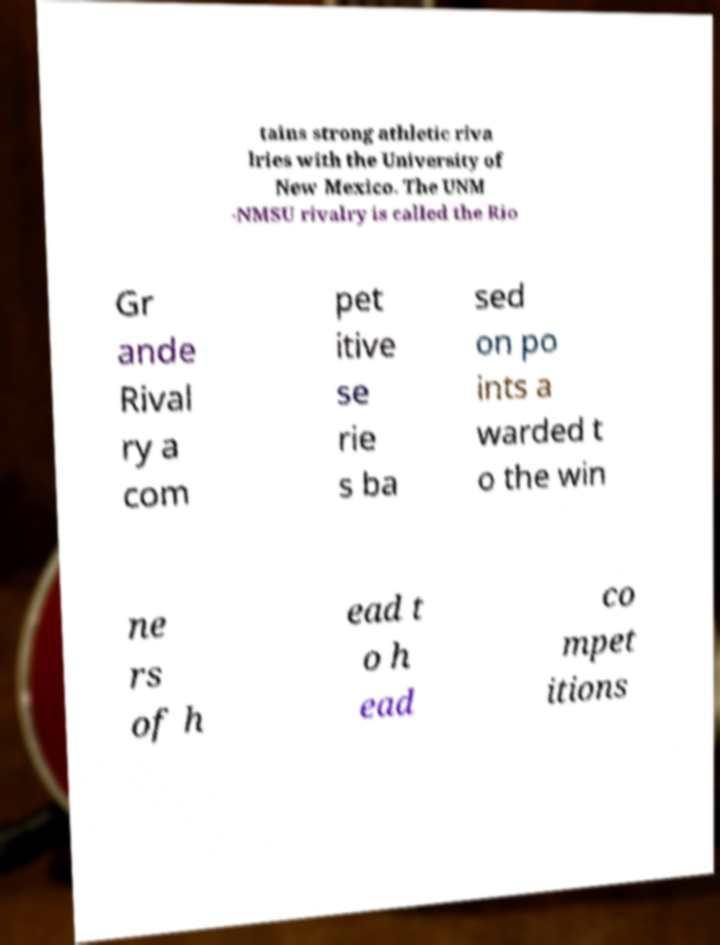Can you read and provide the text displayed in the image?This photo seems to have some interesting text. Can you extract and type it out for me? tains strong athletic riva lries with the University of New Mexico. The UNM -NMSU rivalry is called the Rio Gr ande Rival ry a com pet itive se rie s ba sed on po ints a warded t o the win ne rs of h ead t o h ead co mpet itions 